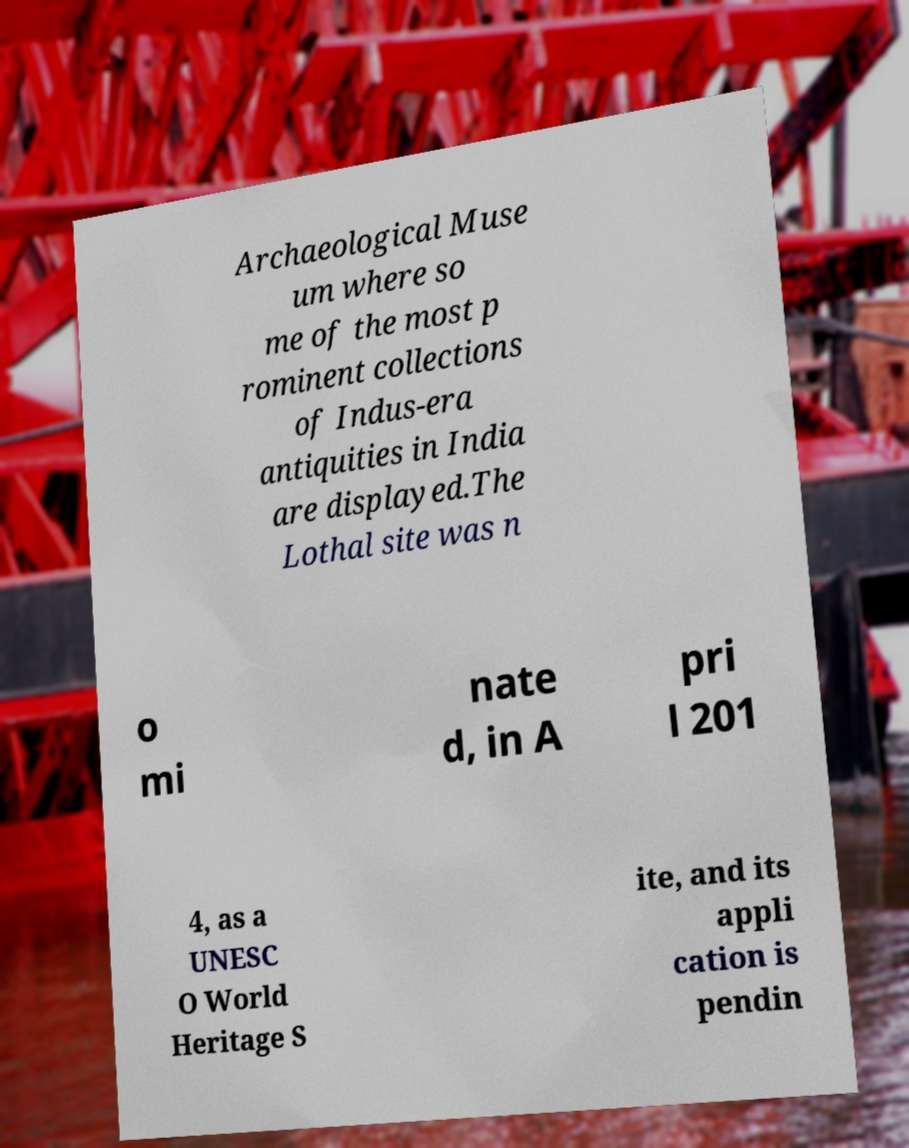There's text embedded in this image that I need extracted. Can you transcribe it verbatim? Archaeological Muse um where so me of the most p rominent collections of Indus-era antiquities in India are displayed.The Lothal site was n o mi nate d, in A pri l 201 4, as a UNESC O World Heritage S ite, and its appli cation is pendin 